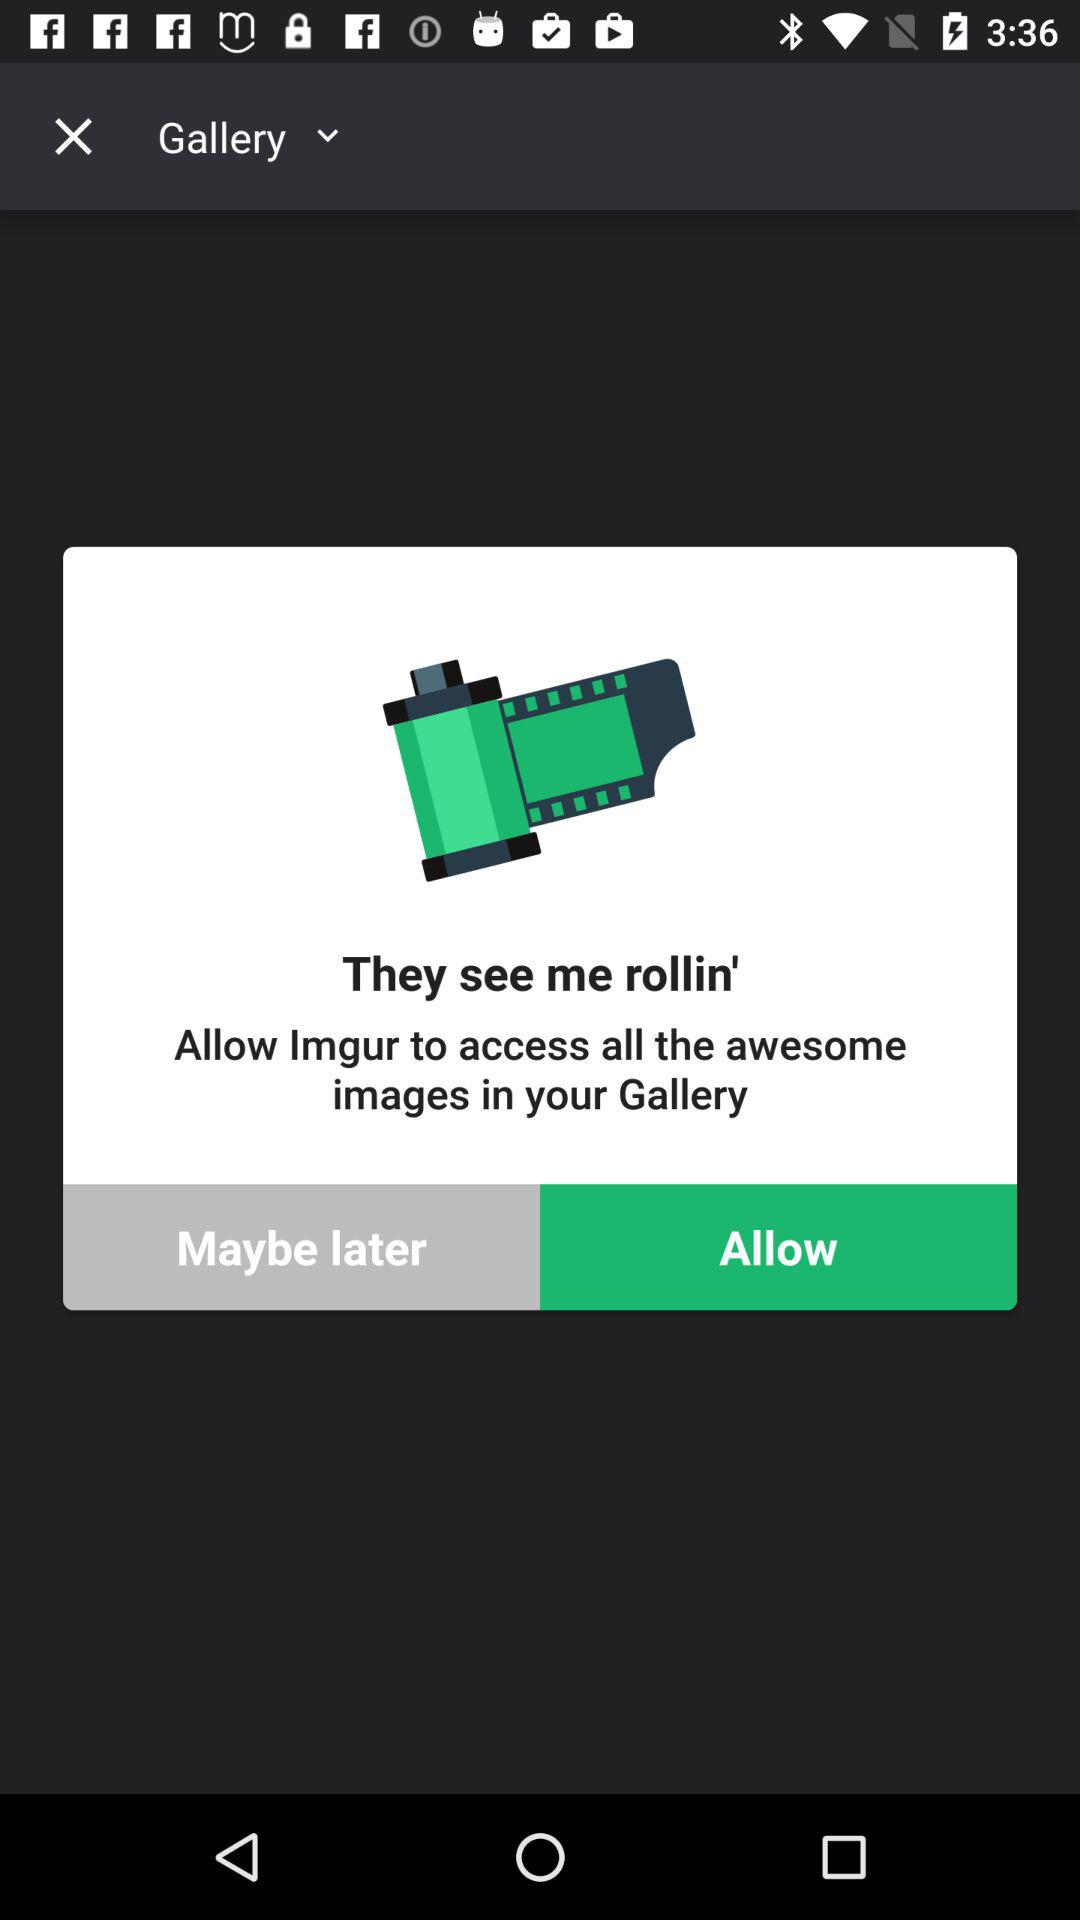What is the application name? The application name is "They see me rollin'". 